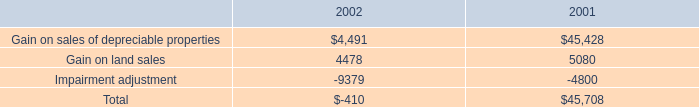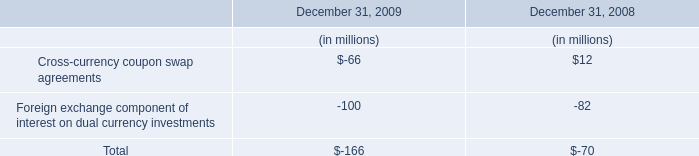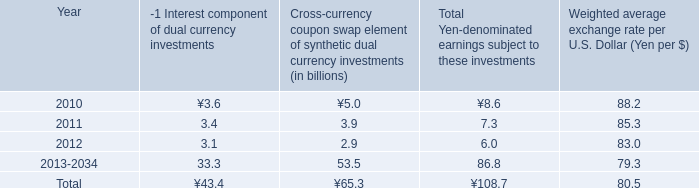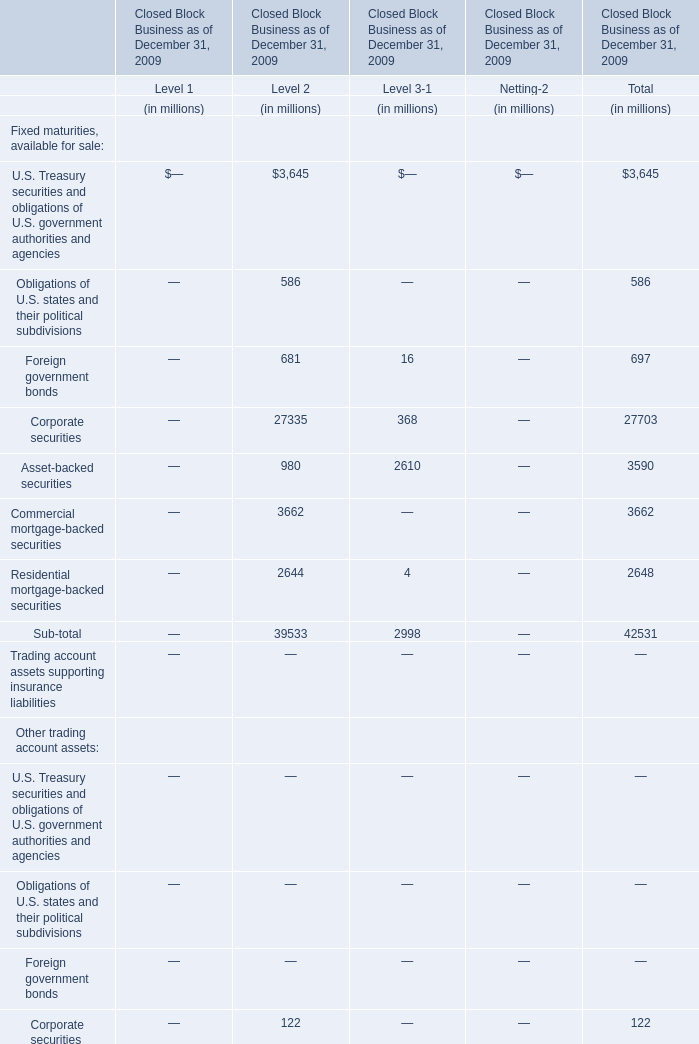Which element for Level 3-1 exceeds 10% of total in 2009? 
Answer: Corporate securities, Asset-backed securities. 